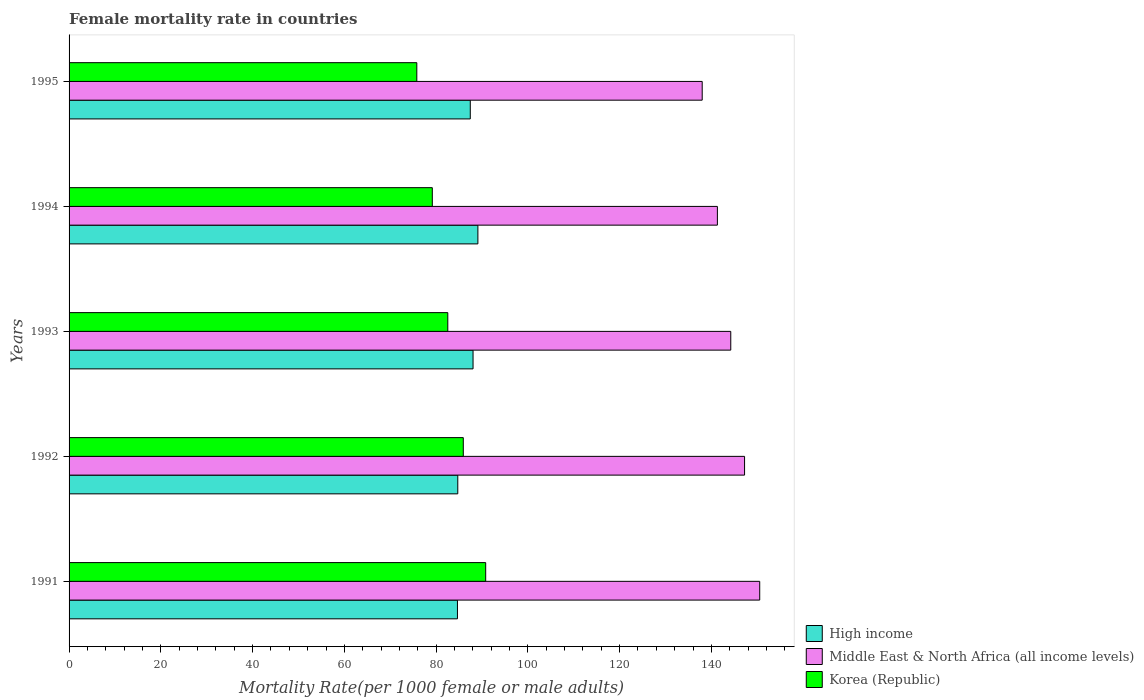How many different coloured bars are there?
Your answer should be compact. 3. Are the number of bars on each tick of the Y-axis equal?
Give a very brief answer. Yes. How many bars are there on the 4th tick from the bottom?
Keep it short and to the point. 3. In how many cases, is the number of bars for a given year not equal to the number of legend labels?
Keep it short and to the point. 0. What is the female mortality rate in Korea (Republic) in 1992?
Provide a short and direct response. 85.92. Across all years, what is the maximum female mortality rate in High income?
Ensure brevity in your answer.  89.11. Across all years, what is the minimum female mortality rate in Middle East & North Africa (all income levels)?
Make the answer very short. 138. In which year was the female mortality rate in Korea (Republic) minimum?
Offer a terse response. 1995. What is the total female mortality rate in High income in the graph?
Provide a succinct answer. 433.98. What is the difference between the female mortality rate in High income in 1993 and that in 1994?
Provide a short and direct response. -1.06. What is the difference between the female mortality rate in Middle East & North Africa (all income levels) in 1994 and the female mortality rate in High income in 1991?
Provide a short and direct response. 56.66. What is the average female mortality rate in Korea (Republic) per year?
Your answer should be compact. 82.85. In the year 1995, what is the difference between the female mortality rate in Middle East & North Africa (all income levels) and female mortality rate in High income?
Provide a succinct answer. 50.55. What is the ratio of the female mortality rate in High income in 1991 to that in 1993?
Your answer should be very brief. 0.96. What is the difference between the highest and the second highest female mortality rate in Korea (Republic)?
Make the answer very short. 4.88. What is the difference between the highest and the lowest female mortality rate in Korea (Republic)?
Your response must be concise. 15.01. In how many years, is the female mortality rate in High income greater than the average female mortality rate in High income taken over all years?
Give a very brief answer. 3. What does the 1st bar from the top in 1994 represents?
Provide a short and direct response. Korea (Republic). How many bars are there?
Your response must be concise. 15. Are all the bars in the graph horizontal?
Make the answer very short. Yes. Are the values on the major ticks of X-axis written in scientific E-notation?
Keep it short and to the point. No. Where does the legend appear in the graph?
Give a very brief answer. Bottom right. How many legend labels are there?
Keep it short and to the point. 3. How are the legend labels stacked?
Ensure brevity in your answer.  Vertical. What is the title of the graph?
Your answer should be very brief. Female mortality rate in countries. Does "Moldova" appear as one of the legend labels in the graph?
Make the answer very short. No. What is the label or title of the X-axis?
Give a very brief answer. Mortality Rate(per 1000 female or male adults). What is the Mortality Rate(per 1000 female or male adults) of High income in 1991?
Your answer should be compact. 84.65. What is the Mortality Rate(per 1000 female or male adults) of Middle East & North Africa (all income levels) in 1991?
Ensure brevity in your answer.  150.53. What is the Mortality Rate(per 1000 female or male adults) of Korea (Republic) in 1991?
Your response must be concise. 90.8. What is the Mortality Rate(per 1000 female or male adults) of High income in 1992?
Make the answer very short. 84.72. What is the Mortality Rate(per 1000 female or male adults) in Middle East & North Africa (all income levels) in 1992?
Ensure brevity in your answer.  147.23. What is the Mortality Rate(per 1000 female or male adults) of Korea (Republic) in 1992?
Offer a very short reply. 85.92. What is the Mortality Rate(per 1000 female or male adults) of High income in 1993?
Provide a short and direct response. 88.05. What is the Mortality Rate(per 1000 female or male adults) in Middle East & North Africa (all income levels) in 1993?
Offer a terse response. 144.22. What is the Mortality Rate(per 1000 female or male adults) in Korea (Republic) in 1993?
Your response must be concise. 82.55. What is the Mortality Rate(per 1000 female or male adults) of High income in 1994?
Make the answer very short. 89.11. What is the Mortality Rate(per 1000 female or male adults) of Middle East & North Africa (all income levels) in 1994?
Ensure brevity in your answer.  141.31. What is the Mortality Rate(per 1000 female or male adults) in Korea (Republic) in 1994?
Offer a terse response. 79.17. What is the Mortality Rate(per 1000 female or male adults) of High income in 1995?
Give a very brief answer. 87.45. What is the Mortality Rate(per 1000 female or male adults) in Middle East & North Africa (all income levels) in 1995?
Your answer should be compact. 138. What is the Mortality Rate(per 1000 female or male adults) in Korea (Republic) in 1995?
Offer a terse response. 75.79. Across all years, what is the maximum Mortality Rate(per 1000 female or male adults) in High income?
Ensure brevity in your answer.  89.11. Across all years, what is the maximum Mortality Rate(per 1000 female or male adults) in Middle East & North Africa (all income levels)?
Your response must be concise. 150.53. Across all years, what is the maximum Mortality Rate(per 1000 female or male adults) of Korea (Republic)?
Keep it short and to the point. 90.8. Across all years, what is the minimum Mortality Rate(per 1000 female or male adults) of High income?
Provide a succinct answer. 84.65. Across all years, what is the minimum Mortality Rate(per 1000 female or male adults) in Middle East & North Africa (all income levels)?
Make the answer very short. 138. Across all years, what is the minimum Mortality Rate(per 1000 female or male adults) of Korea (Republic)?
Your answer should be very brief. 75.79. What is the total Mortality Rate(per 1000 female or male adults) of High income in the graph?
Ensure brevity in your answer.  433.98. What is the total Mortality Rate(per 1000 female or male adults) in Middle East & North Africa (all income levels) in the graph?
Your response must be concise. 721.29. What is the total Mortality Rate(per 1000 female or male adults) of Korea (Republic) in the graph?
Keep it short and to the point. 414.24. What is the difference between the Mortality Rate(per 1000 female or male adults) of High income in 1991 and that in 1992?
Ensure brevity in your answer.  -0.07. What is the difference between the Mortality Rate(per 1000 female or male adults) of Middle East & North Africa (all income levels) in 1991 and that in 1992?
Your answer should be very brief. 3.31. What is the difference between the Mortality Rate(per 1000 female or male adults) in Korea (Republic) in 1991 and that in 1992?
Give a very brief answer. 4.88. What is the difference between the Mortality Rate(per 1000 female or male adults) of High income in 1991 and that in 1993?
Make the answer very short. -3.4. What is the difference between the Mortality Rate(per 1000 female or male adults) in Middle East & North Africa (all income levels) in 1991 and that in 1993?
Provide a short and direct response. 6.31. What is the difference between the Mortality Rate(per 1000 female or male adults) of Korea (Republic) in 1991 and that in 1993?
Provide a succinct answer. 8.26. What is the difference between the Mortality Rate(per 1000 female or male adults) of High income in 1991 and that in 1994?
Offer a terse response. -4.46. What is the difference between the Mortality Rate(per 1000 female or male adults) of Middle East & North Africa (all income levels) in 1991 and that in 1994?
Your response must be concise. 9.23. What is the difference between the Mortality Rate(per 1000 female or male adults) of Korea (Republic) in 1991 and that in 1994?
Ensure brevity in your answer.  11.63. What is the difference between the Mortality Rate(per 1000 female or male adults) in High income in 1991 and that in 1995?
Keep it short and to the point. -2.8. What is the difference between the Mortality Rate(per 1000 female or male adults) in Middle East & North Africa (all income levels) in 1991 and that in 1995?
Keep it short and to the point. 12.54. What is the difference between the Mortality Rate(per 1000 female or male adults) in Korea (Republic) in 1991 and that in 1995?
Ensure brevity in your answer.  15.01. What is the difference between the Mortality Rate(per 1000 female or male adults) of High income in 1992 and that in 1993?
Keep it short and to the point. -3.33. What is the difference between the Mortality Rate(per 1000 female or male adults) in Middle East & North Africa (all income levels) in 1992 and that in 1993?
Provide a short and direct response. 3.01. What is the difference between the Mortality Rate(per 1000 female or male adults) of Korea (Republic) in 1992 and that in 1993?
Keep it short and to the point. 3.38. What is the difference between the Mortality Rate(per 1000 female or male adults) of High income in 1992 and that in 1994?
Your response must be concise. -4.38. What is the difference between the Mortality Rate(per 1000 female or male adults) of Middle East & North Africa (all income levels) in 1992 and that in 1994?
Provide a short and direct response. 5.92. What is the difference between the Mortality Rate(per 1000 female or male adults) of Korea (Republic) in 1992 and that in 1994?
Ensure brevity in your answer.  6.75. What is the difference between the Mortality Rate(per 1000 female or male adults) of High income in 1992 and that in 1995?
Keep it short and to the point. -2.73. What is the difference between the Mortality Rate(per 1000 female or male adults) in Middle East & North Africa (all income levels) in 1992 and that in 1995?
Your answer should be very brief. 9.23. What is the difference between the Mortality Rate(per 1000 female or male adults) in Korea (Republic) in 1992 and that in 1995?
Offer a very short reply. 10.13. What is the difference between the Mortality Rate(per 1000 female or male adults) in High income in 1993 and that in 1994?
Provide a short and direct response. -1.06. What is the difference between the Mortality Rate(per 1000 female or male adults) of Middle East & North Africa (all income levels) in 1993 and that in 1994?
Offer a very short reply. 2.91. What is the difference between the Mortality Rate(per 1000 female or male adults) in Korea (Republic) in 1993 and that in 1994?
Your answer should be very brief. 3.38. What is the difference between the Mortality Rate(per 1000 female or male adults) of High income in 1993 and that in 1995?
Give a very brief answer. 0.6. What is the difference between the Mortality Rate(per 1000 female or male adults) in Middle East & North Africa (all income levels) in 1993 and that in 1995?
Give a very brief answer. 6.22. What is the difference between the Mortality Rate(per 1000 female or male adults) of Korea (Republic) in 1993 and that in 1995?
Ensure brevity in your answer.  6.75. What is the difference between the Mortality Rate(per 1000 female or male adults) in High income in 1994 and that in 1995?
Make the answer very short. 1.66. What is the difference between the Mortality Rate(per 1000 female or male adults) of Middle East & North Africa (all income levels) in 1994 and that in 1995?
Provide a short and direct response. 3.31. What is the difference between the Mortality Rate(per 1000 female or male adults) in Korea (Republic) in 1994 and that in 1995?
Offer a very short reply. 3.38. What is the difference between the Mortality Rate(per 1000 female or male adults) of High income in 1991 and the Mortality Rate(per 1000 female or male adults) of Middle East & North Africa (all income levels) in 1992?
Keep it short and to the point. -62.58. What is the difference between the Mortality Rate(per 1000 female or male adults) of High income in 1991 and the Mortality Rate(per 1000 female or male adults) of Korea (Republic) in 1992?
Offer a very short reply. -1.27. What is the difference between the Mortality Rate(per 1000 female or male adults) in Middle East & North Africa (all income levels) in 1991 and the Mortality Rate(per 1000 female or male adults) in Korea (Republic) in 1992?
Your answer should be compact. 64.61. What is the difference between the Mortality Rate(per 1000 female or male adults) in High income in 1991 and the Mortality Rate(per 1000 female or male adults) in Middle East & North Africa (all income levels) in 1993?
Your response must be concise. -59.57. What is the difference between the Mortality Rate(per 1000 female or male adults) in High income in 1991 and the Mortality Rate(per 1000 female or male adults) in Korea (Republic) in 1993?
Your answer should be compact. 2.1. What is the difference between the Mortality Rate(per 1000 female or male adults) in Middle East & North Africa (all income levels) in 1991 and the Mortality Rate(per 1000 female or male adults) in Korea (Republic) in 1993?
Your answer should be compact. 67.99. What is the difference between the Mortality Rate(per 1000 female or male adults) of High income in 1991 and the Mortality Rate(per 1000 female or male adults) of Middle East & North Africa (all income levels) in 1994?
Provide a succinct answer. -56.66. What is the difference between the Mortality Rate(per 1000 female or male adults) in High income in 1991 and the Mortality Rate(per 1000 female or male adults) in Korea (Republic) in 1994?
Your response must be concise. 5.48. What is the difference between the Mortality Rate(per 1000 female or male adults) of Middle East & North Africa (all income levels) in 1991 and the Mortality Rate(per 1000 female or male adults) of Korea (Republic) in 1994?
Provide a succinct answer. 71.36. What is the difference between the Mortality Rate(per 1000 female or male adults) of High income in 1991 and the Mortality Rate(per 1000 female or male adults) of Middle East & North Africa (all income levels) in 1995?
Offer a terse response. -53.34. What is the difference between the Mortality Rate(per 1000 female or male adults) of High income in 1991 and the Mortality Rate(per 1000 female or male adults) of Korea (Republic) in 1995?
Your answer should be compact. 8.86. What is the difference between the Mortality Rate(per 1000 female or male adults) of Middle East & North Africa (all income levels) in 1991 and the Mortality Rate(per 1000 female or male adults) of Korea (Republic) in 1995?
Offer a terse response. 74.74. What is the difference between the Mortality Rate(per 1000 female or male adults) in High income in 1992 and the Mortality Rate(per 1000 female or male adults) in Middle East & North Africa (all income levels) in 1993?
Your answer should be compact. -59.5. What is the difference between the Mortality Rate(per 1000 female or male adults) in High income in 1992 and the Mortality Rate(per 1000 female or male adults) in Korea (Republic) in 1993?
Offer a very short reply. 2.18. What is the difference between the Mortality Rate(per 1000 female or male adults) in Middle East & North Africa (all income levels) in 1992 and the Mortality Rate(per 1000 female or male adults) in Korea (Republic) in 1993?
Offer a terse response. 64.68. What is the difference between the Mortality Rate(per 1000 female or male adults) in High income in 1992 and the Mortality Rate(per 1000 female or male adults) in Middle East & North Africa (all income levels) in 1994?
Give a very brief answer. -56.58. What is the difference between the Mortality Rate(per 1000 female or male adults) in High income in 1992 and the Mortality Rate(per 1000 female or male adults) in Korea (Republic) in 1994?
Keep it short and to the point. 5.55. What is the difference between the Mortality Rate(per 1000 female or male adults) in Middle East & North Africa (all income levels) in 1992 and the Mortality Rate(per 1000 female or male adults) in Korea (Republic) in 1994?
Your answer should be compact. 68.06. What is the difference between the Mortality Rate(per 1000 female or male adults) in High income in 1992 and the Mortality Rate(per 1000 female or male adults) in Middle East & North Africa (all income levels) in 1995?
Keep it short and to the point. -53.27. What is the difference between the Mortality Rate(per 1000 female or male adults) of High income in 1992 and the Mortality Rate(per 1000 female or male adults) of Korea (Republic) in 1995?
Keep it short and to the point. 8.93. What is the difference between the Mortality Rate(per 1000 female or male adults) in Middle East & North Africa (all income levels) in 1992 and the Mortality Rate(per 1000 female or male adults) in Korea (Republic) in 1995?
Give a very brief answer. 71.44. What is the difference between the Mortality Rate(per 1000 female or male adults) in High income in 1993 and the Mortality Rate(per 1000 female or male adults) in Middle East & North Africa (all income levels) in 1994?
Your answer should be compact. -53.26. What is the difference between the Mortality Rate(per 1000 female or male adults) in High income in 1993 and the Mortality Rate(per 1000 female or male adults) in Korea (Republic) in 1994?
Your answer should be compact. 8.88. What is the difference between the Mortality Rate(per 1000 female or male adults) in Middle East & North Africa (all income levels) in 1993 and the Mortality Rate(per 1000 female or male adults) in Korea (Republic) in 1994?
Provide a succinct answer. 65.05. What is the difference between the Mortality Rate(per 1000 female or male adults) in High income in 1993 and the Mortality Rate(per 1000 female or male adults) in Middle East & North Africa (all income levels) in 1995?
Offer a very short reply. -49.95. What is the difference between the Mortality Rate(per 1000 female or male adults) of High income in 1993 and the Mortality Rate(per 1000 female or male adults) of Korea (Republic) in 1995?
Offer a very short reply. 12.26. What is the difference between the Mortality Rate(per 1000 female or male adults) in Middle East & North Africa (all income levels) in 1993 and the Mortality Rate(per 1000 female or male adults) in Korea (Republic) in 1995?
Make the answer very short. 68.43. What is the difference between the Mortality Rate(per 1000 female or male adults) in High income in 1994 and the Mortality Rate(per 1000 female or male adults) in Middle East & North Africa (all income levels) in 1995?
Your response must be concise. -48.89. What is the difference between the Mortality Rate(per 1000 female or male adults) of High income in 1994 and the Mortality Rate(per 1000 female or male adults) of Korea (Republic) in 1995?
Your answer should be very brief. 13.31. What is the difference between the Mortality Rate(per 1000 female or male adults) of Middle East & North Africa (all income levels) in 1994 and the Mortality Rate(per 1000 female or male adults) of Korea (Republic) in 1995?
Keep it short and to the point. 65.52. What is the average Mortality Rate(per 1000 female or male adults) in High income per year?
Ensure brevity in your answer.  86.8. What is the average Mortality Rate(per 1000 female or male adults) in Middle East & North Africa (all income levels) per year?
Keep it short and to the point. 144.26. What is the average Mortality Rate(per 1000 female or male adults) of Korea (Republic) per year?
Your response must be concise. 82.85. In the year 1991, what is the difference between the Mortality Rate(per 1000 female or male adults) of High income and Mortality Rate(per 1000 female or male adults) of Middle East & North Africa (all income levels)?
Your response must be concise. -65.88. In the year 1991, what is the difference between the Mortality Rate(per 1000 female or male adults) in High income and Mortality Rate(per 1000 female or male adults) in Korea (Republic)?
Keep it short and to the point. -6.15. In the year 1991, what is the difference between the Mortality Rate(per 1000 female or male adults) of Middle East & North Africa (all income levels) and Mortality Rate(per 1000 female or male adults) of Korea (Republic)?
Your answer should be compact. 59.73. In the year 1992, what is the difference between the Mortality Rate(per 1000 female or male adults) in High income and Mortality Rate(per 1000 female or male adults) in Middle East & North Africa (all income levels)?
Offer a very short reply. -62.51. In the year 1992, what is the difference between the Mortality Rate(per 1000 female or male adults) in High income and Mortality Rate(per 1000 female or male adults) in Korea (Republic)?
Provide a succinct answer. -1.2. In the year 1992, what is the difference between the Mortality Rate(per 1000 female or male adults) in Middle East & North Africa (all income levels) and Mortality Rate(per 1000 female or male adults) in Korea (Republic)?
Keep it short and to the point. 61.3. In the year 1993, what is the difference between the Mortality Rate(per 1000 female or male adults) in High income and Mortality Rate(per 1000 female or male adults) in Middle East & North Africa (all income levels)?
Offer a very short reply. -56.17. In the year 1993, what is the difference between the Mortality Rate(per 1000 female or male adults) in High income and Mortality Rate(per 1000 female or male adults) in Korea (Republic)?
Your answer should be very brief. 5.5. In the year 1993, what is the difference between the Mortality Rate(per 1000 female or male adults) of Middle East & North Africa (all income levels) and Mortality Rate(per 1000 female or male adults) of Korea (Republic)?
Keep it short and to the point. 61.67. In the year 1994, what is the difference between the Mortality Rate(per 1000 female or male adults) of High income and Mortality Rate(per 1000 female or male adults) of Middle East & North Africa (all income levels)?
Offer a terse response. -52.2. In the year 1994, what is the difference between the Mortality Rate(per 1000 female or male adults) in High income and Mortality Rate(per 1000 female or male adults) in Korea (Republic)?
Provide a short and direct response. 9.94. In the year 1994, what is the difference between the Mortality Rate(per 1000 female or male adults) in Middle East & North Africa (all income levels) and Mortality Rate(per 1000 female or male adults) in Korea (Republic)?
Provide a short and direct response. 62.14. In the year 1995, what is the difference between the Mortality Rate(per 1000 female or male adults) in High income and Mortality Rate(per 1000 female or male adults) in Middle East & North Africa (all income levels)?
Provide a short and direct response. -50.55. In the year 1995, what is the difference between the Mortality Rate(per 1000 female or male adults) of High income and Mortality Rate(per 1000 female or male adults) of Korea (Republic)?
Give a very brief answer. 11.66. In the year 1995, what is the difference between the Mortality Rate(per 1000 female or male adults) of Middle East & North Africa (all income levels) and Mortality Rate(per 1000 female or male adults) of Korea (Republic)?
Your answer should be compact. 62.2. What is the ratio of the Mortality Rate(per 1000 female or male adults) in Middle East & North Africa (all income levels) in 1991 to that in 1992?
Give a very brief answer. 1.02. What is the ratio of the Mortality Rate(per 1000 female or male adults) in Korea (Republic) in 1991 to that in 1992?
Ensure brevity in your answer.  1.06. What is the ratio of the Mortality Rate(per 1000 female or male adults) of High income in 1991 to that in 1993?
Ensure brevity in your answer.  0.96. What is the ratio of the Mortality Rate(per 1000 female or male adults) in Middle East & North Africa (all income levels) in 1991 to that in 1993?
Keep it short and to the point. 1.04. What is the ratio of the Mortality Rate(per 1000 female or male adults) of Korea (Republic) in 1991 to that in 1993?
Ensure brevity in your answer.  1.1. What is the ratio of the Mortality Rate(per 1000 female or male adults) in Middle East & North Africa (all income levels) in 1991 to that in 1994?
Provide a succinct answer. 1.07. What is the ratio of the Mortality Rate(per 1000 female or male adults) of Korea (Republic) in 1991 to that in 1994?
Ensure brevity in your answer.  1.15. What is the ratio of the Mortality Rate(per 1000 female or male adults) of Middle East & North Africa (all income levels) in 1991 to that in 1995?
Provide a short and direct response. 1.09. What is the ratio of the Mortality Rate(per 1000 female or male adults) of Korea (Republic) in 1991 to that in 1995?
Offer a terse response. 1.2. What is the ratio of the Mortality Rate(per 1000 female or male adults) in High income in 1992 to that in 1993?
Provide a succinct answer. 0.96. What is the ratio of the Mortality Rate(per 1000 female or male adults) of Middle East & North Africa (all income levels) in 1992 to that in 1993?
Provide a succinct answer. 1.02. What is the ratio of the Mortality Rate(per 1000 female or male adults) in Korea (Republic) in 1992 to that in 1993?
Provide a succinct answer. 1.04. What is the ratio of the Mortality Rate(per 1000 female or male adults) of High income in 1992 to that in 1994?
Your answer should be very brief. 0.95. What is the ratio of the Mortality Rate(per 1000 female or male adults) of Middle East & North Africa (all income levels) in 1992 to that in 1994?
Offer a very short reply. 1.04. What is the ratio of the Mortality Rate(per 1000 female or male adults) of Korea (Republic) in 1992 to that in 1994?
Your answer should be very brief. 1.09. What is the ratio of the Mortality Rate(per 1000 female or male adults) in High income in 1992 to that in 1995?
Your answer should be very brief. 0.97. What is the ratio of the Mortality Rate(per 1000 female or male adults) in Middle East & North Africa (all income levels) in 1992 to that in 1995?
Make the answer very short. 1.07. What is the ratio of the Mortality Rate(per 1000 female or male adults) of Korea (Republic) in 1992 to that in 1995?
Make the answer very short. 1.13. What is the ratio of the Mortality Rate(per 1000 female or male adults) in High income in 1993 to that in 1994?
Make the answer very short. 0.99. What is the ratio of the Mortality Rate(per 1000 female or male adults) in Middle East & North Africa (all income levels) in 1993 to that in 1994?
Your answer should be very brief. 1.02. What is the ratio of the Mortality Rate(per 1000 female or male adults) of Korea (Republic) in 1993 to that in 1994?
Your answer should be very brief. 1.04. What is the ratio of the Mortality Rate(per 1000 female or male adults) of Middle East & North Africa (all income levels) in 1993 to that in 1995?
Provide a succinct answer. 1.05. What is the ratio of the Mortality Rate(per 1000 female or male adults) of Korea (Republic) in 1993 to that in 1995?
Your answer should be compact. 1.09. What is the ratio of the Mortality Rate(per 1000 female or male adults) in High income in 1994 to that in 1995?
Ensure brevity in your answer.  1.02. What is the ratio of the Mortality Rate(per 1000 female or male adults) in Korea (Republic) in 1994 to that in 1995?
Keep it short and to the point. 1.04. What is the difference between the highest and the second highest Mortality Rate(per 1000 female or male adults) in High income?
Your response must be concise. 1.06. What is the difference between the highest and the second highest Mortality Rate(per 1000 female or male adults) of Middle East & North Africa (all income levels)?
Provide a short and direct response. 3.31. What is the difference between the highest and the second highest Mortality Rate(per 1000 female or male adults) of Korea (Republic)?
Provide a succinct answer. 4.88. What is the difference between the highest and the lowest Mortality Rate(per 1000 female or male adults) in High income?
Provide a short and direct response. 4.46. What is the difference between the highest and the lowest Mortality Rate(per 1000 female or male adults) of Middle East & North Africa (all income levels)?
Ensure brevity in your answer.  12.54. What is the difference between the highest and the lowest Mortality Rate(per 1000 female or male adults) in Korea (Republic)?
Ensure brevity in your answer.  15.01. 